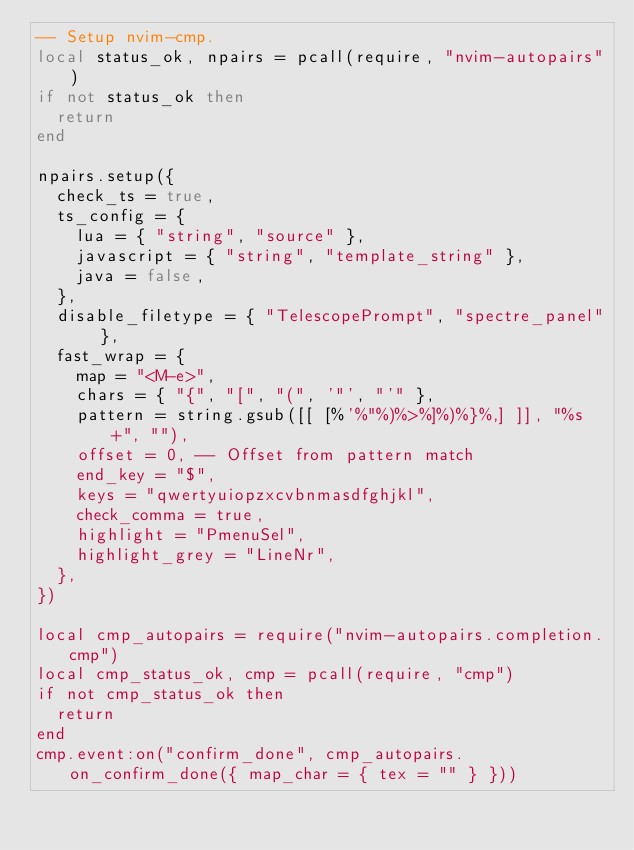<code> <loc_0><loc_0><loc_500><loc_500><_Lua_>-- Setup nvim-cmp.
local status_ok, npairs = pcall(require, "nvim-autopairs")
if not status_ok then
	return
end

npairs.setup({
	check_ts = true,
	ts_config = {
		lua = { "string", "source" },
		javascript = { "string", "template_string" },
		java = false,
	},
	disable_filetype = { "TelescopePrompt", "spectre_panel" },
	fast_wrap = {
		map = "<M-e>",
		chars = { "{", "[", "(", '"', "'" },
		pattern = string.gsub([[ [%'%"%)%>%]%)%}%,] ]], "%s+", ""),
		offset = 0, -- Offset from pattern match
		end_key = "$",
		keys = "qwertyuiopzxcvbnmasdfghjkl",
		check_comma = true,
		highlight = "PmenuSel",
		highlight_grey = "LineNr",
	},
})

local cmp_autopairs = require("nvim-autopairs.completion.cmp")
local cmp_status_ok, cmp = pcall(require, "cmp")
if not cmp_status_ok then
	return
end
cmp.event:on("confirm_done", cmp_autopairs.on_confirm_done({ map_char = { tex = "" } }))
</code> 